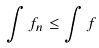<formula> <loc_0><loc_0><loc_500><loc_500>\int f _ { n } \leq \int f</formula> 